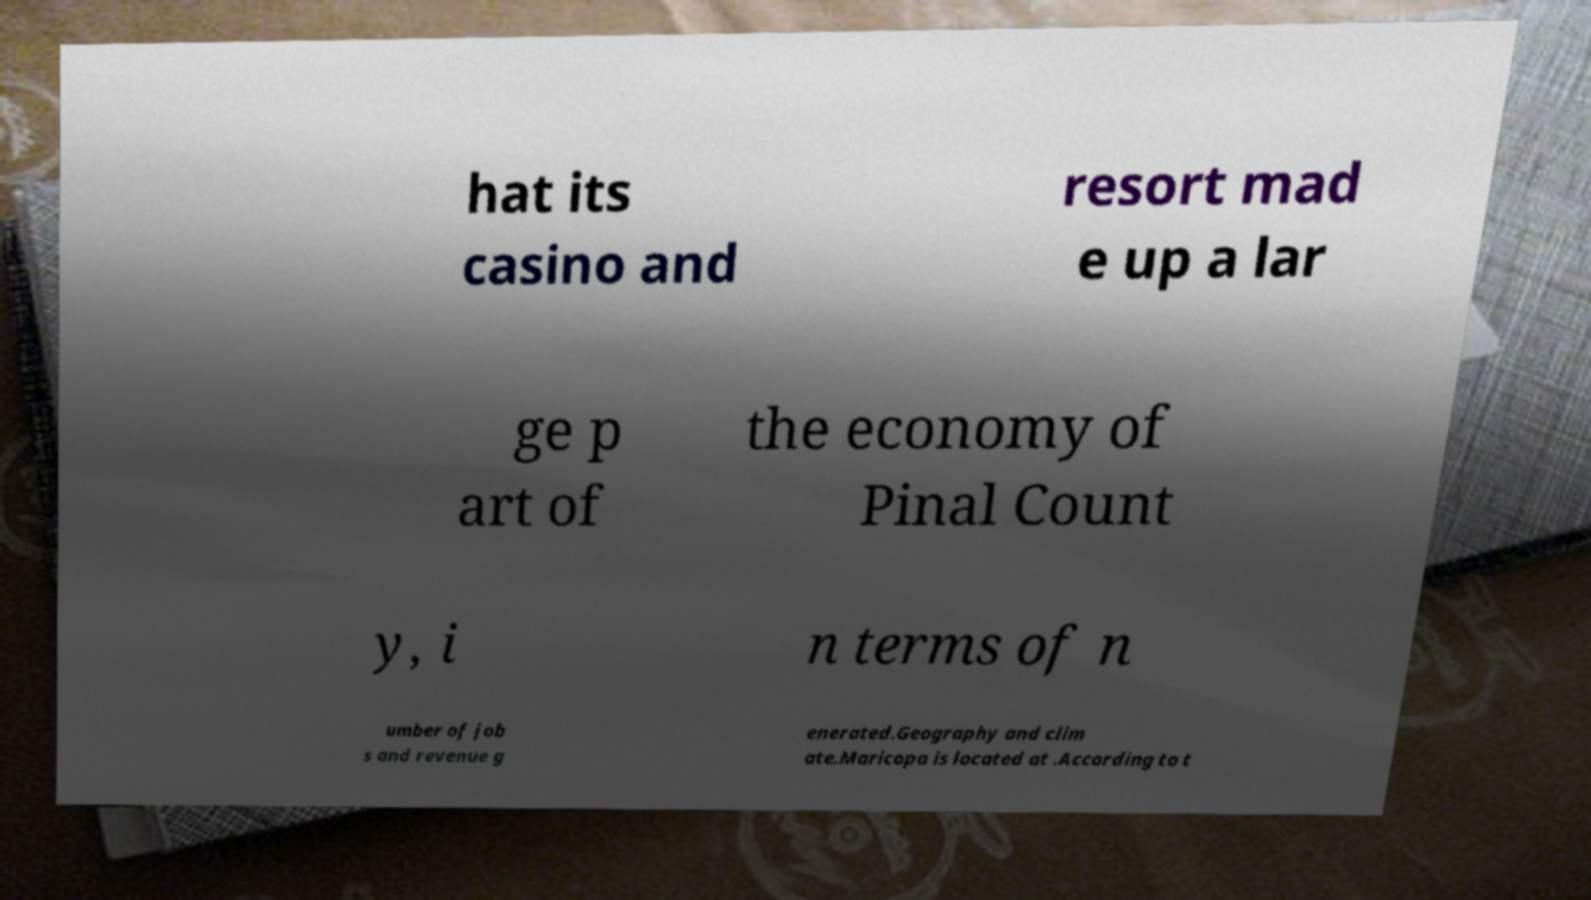What messages or text are displayed in this image? I need them in a readable, typed format. hat its casino and resort mad e up a lar ge p art of the economy of Pinal Count y, i n terms of n umber of job s and revenue g enerated.Geography and clim ate.Maricopa is located at .According to t 